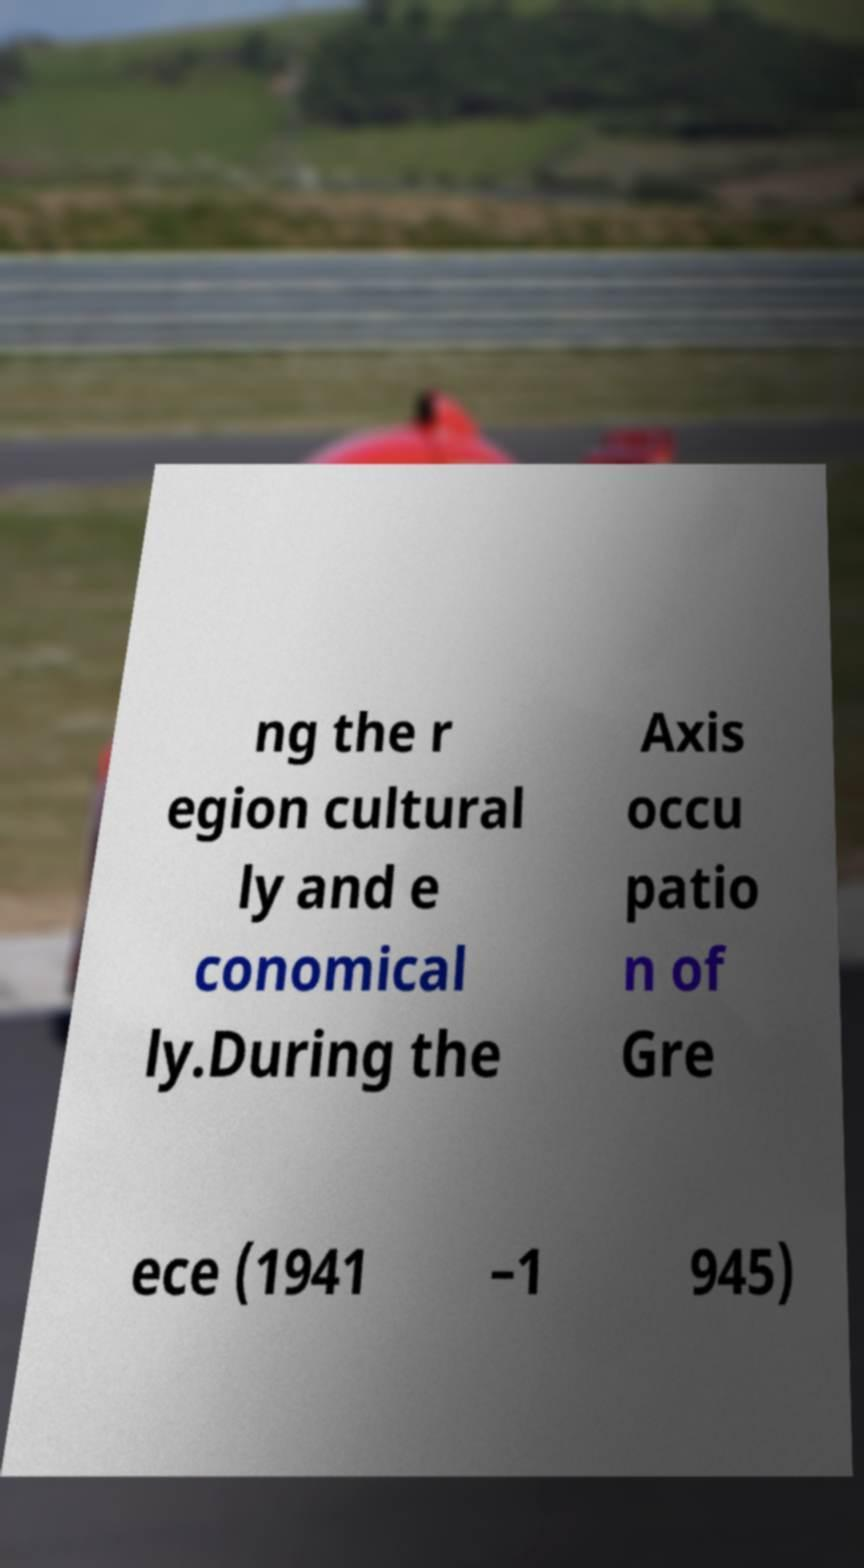Could you assist in decoding the text presented in this image and type it out clearly? ng the r egion cultural ly and e conomical ly.During the Axis occu patio n of Gre ece (1941 –1 945) 